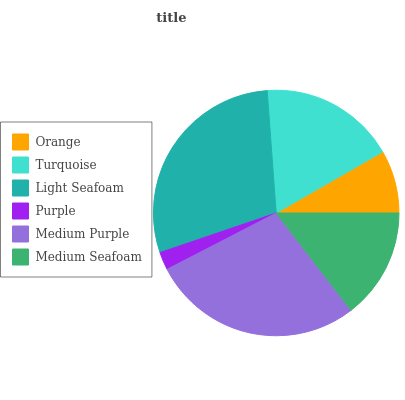Is Purple the minimum?
Answer yes or no. Yes. Is Light Seafoam the maximum?
Answer yes or no. Yes. Is Turquoise the minimum?
Answer yes or no. No. Is Turquoise the maximum?
Answer yes or no. No. Is Turquoise greater than Orange?
Answer yes or no. Yes. Is Orange less than Turquoise?
Answer yes or no. Yes. Is Orange greater than Turquoise?
Answer yes or no. No. Is Turquoise less than Orange?
Answer yes or no. No. Is Turquoise the high median?
Answer yes or no. Yes. Is Medium Seafoam the low median?
Answer yes or no. Yes. Is Medium Purple the high median?
Answer yes or no. No. Is Light Seafoam the low median?
Answer yes or no. No. 